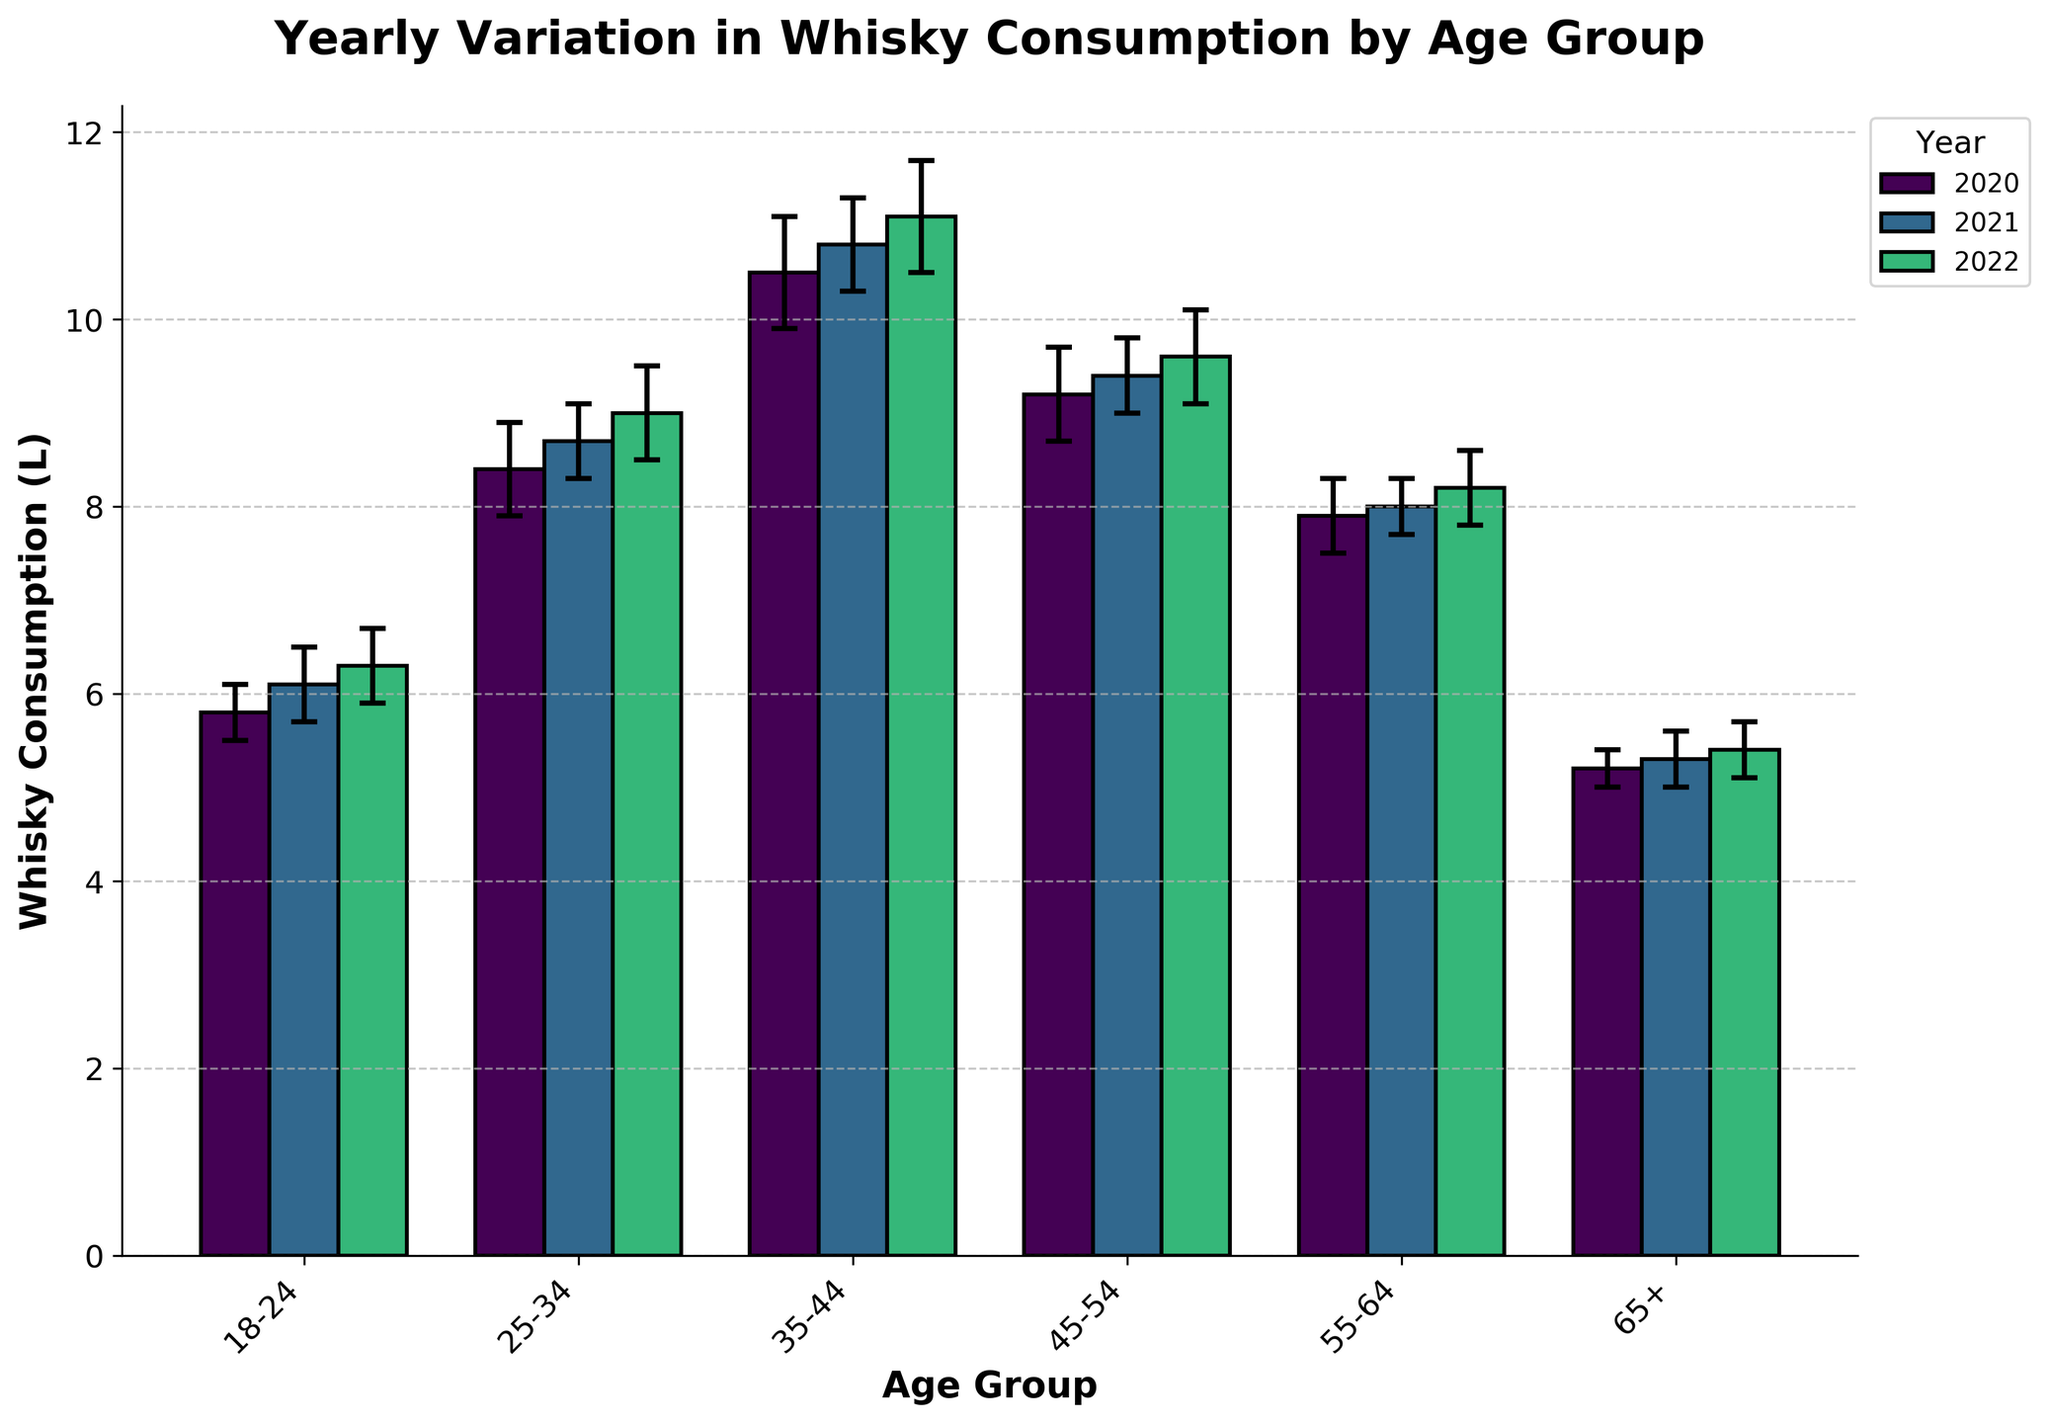What is the title of the chart? The title is a key element of the chart, typically displayed at the top. For this chart, it describes the main subject, which gives viewers a clear understanding of the focus.
Answer: Yearly Variation in Whisky Consumption by Age Group How many age groups are represented in the chart? The x-axis of the chart lists all the age groups, which are the categories being compared. By counting these categories, we find the total number of age groups.
Answer: Six Which age group had the highest whisky consumption in 2022? To answer this question, we look at the height of the bars corresponding to 2022 (might be color-coded) for each age group and identify the tallest bar.
Answer: 35-44 What is the average whisky consumption of the age group 18-24 over the three years? First, identify the whisky consumption values for 18-24 for the years 2020, 2021, and 2022. Then add these values and divide by the number of years (3) to get the average.
Answer: (5.8 + 6.1 + 6.3) / 3 = 6.07 Which year had the lowest whisky consumption for the age group 65+? Look at the different bars corresponding to each year for the age group 65+ and identify the shortest bar.
Answer: 2020 What is the difference in whisky consumption between the age groups 25-34 and 55-64 in 2021? Identify the whisky consumption values for both age groups in 2021, then calculate the difference by subtracting the smaller value from the larger value.
Answer: 8.7 - 8.0 = 0.7 Which year showed the most significant increase in whisky consumption for the age group 45-54? Compare the bar heights for the years 2020, 2021, and 2022 for the age group 45-54 and determine the year with the largest increase from the previous year.
Answer: 2020 to 2021 (from 9.2 to 9.4 is an increase of 0.2; subsequent increase from 2021 to 2022 is 0.2) What's the overall trend in whisky consumption for all age groups from 2020 to 2022? By examining the bar heights for all age groups over the three years, we can identify whether there is a general pattern or trend of increase or decrease.
Answer: Increasing What was the total whisky consumption for the age group 35-44 in 2020 including the error margin? Identify the whisky consumption value for 35-44 in 2020 and add the error margin to get the total considering the upper bound.
Answer: 10.5 + 0.6 = 11.1 Which age group had the smallest overall error margin for its whisky consumption values across all three years? Compare the error margins for each age group across all three years. Calculate the average error margin for each age group and identify the smallest.
Answer: 65+ (Average error = (0.2 + 0.3 + 0.3) / 3 = 0.27) 